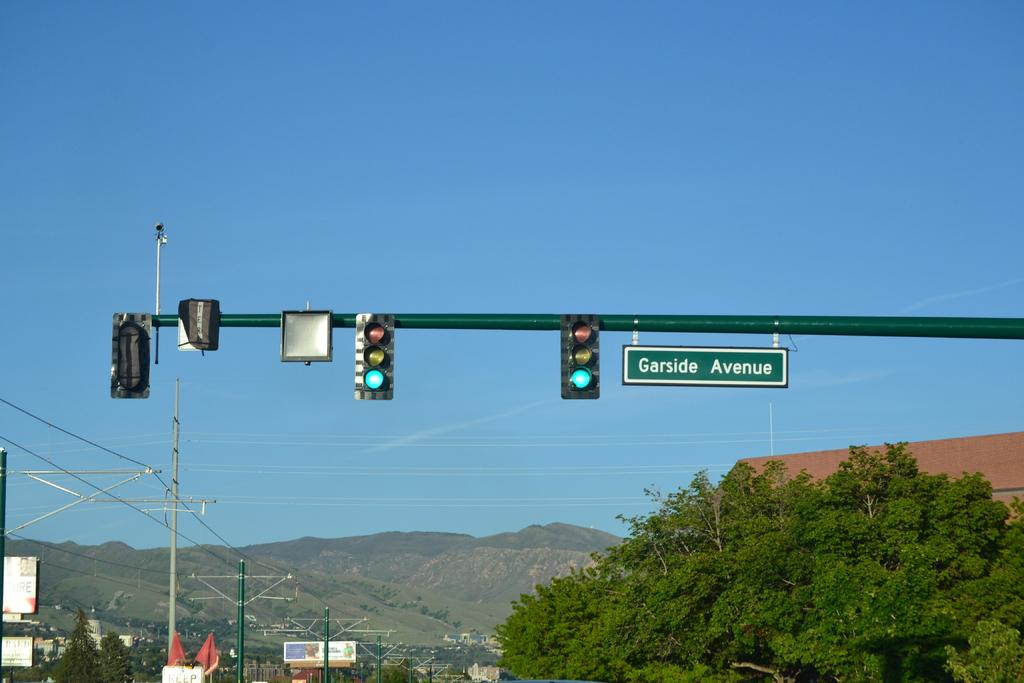<image>
Summarize the visual content of the image. A traffic light has a sign that says Garside Avenue hanging from it. 